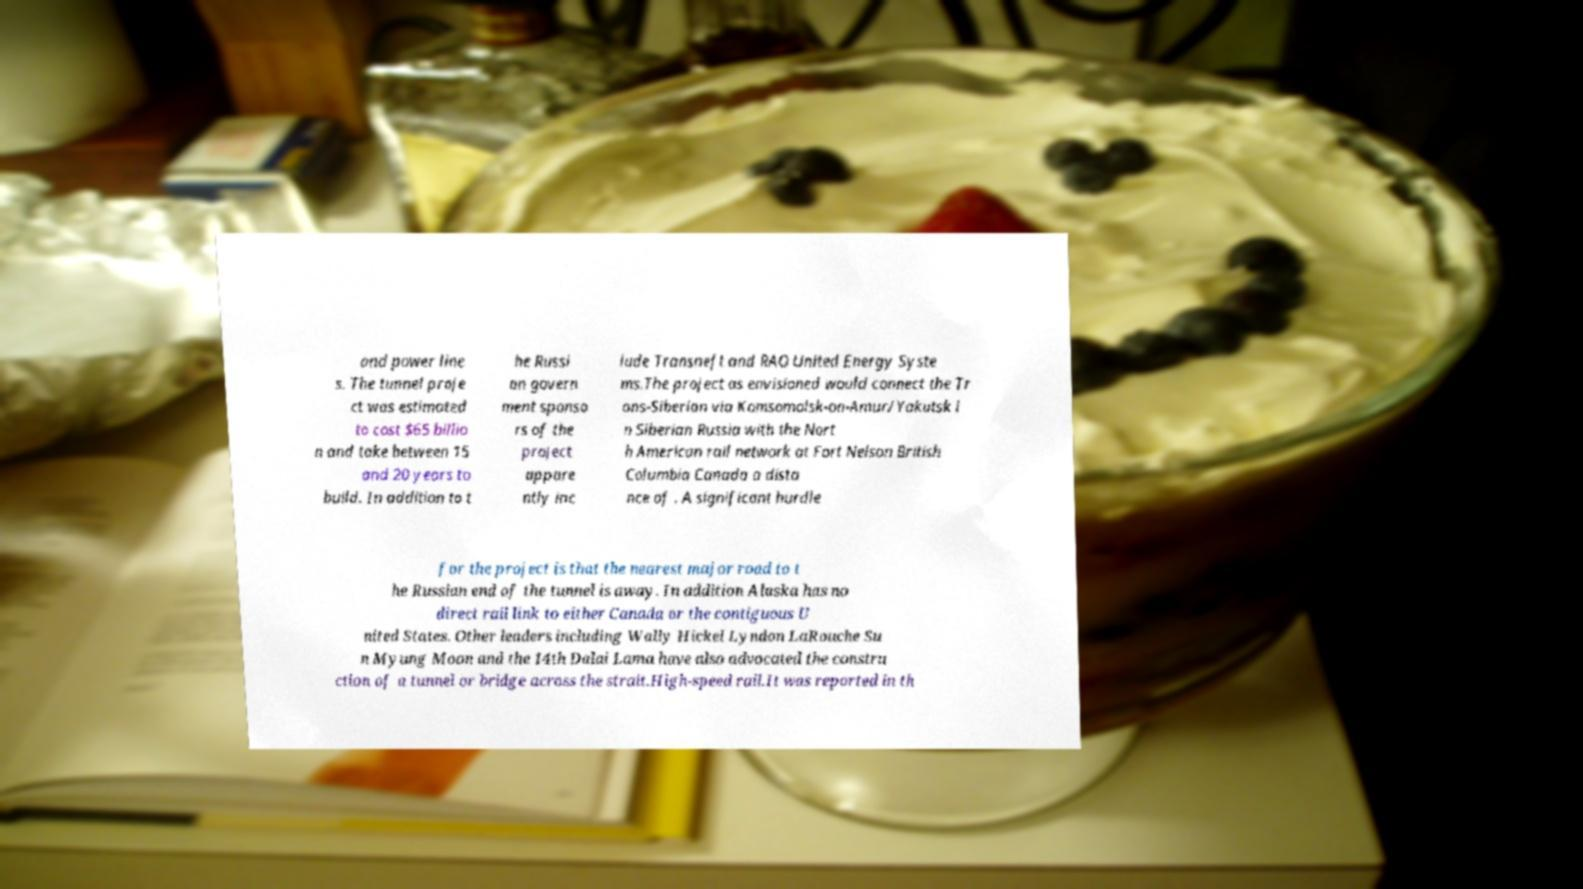I need the written content from this picture converted into text. Can you do that? and power line s. The tunnel proje ct was estimated to cost $65 billio n and take between 15 and 20 years to build. In addition to t he Russi an govern ment sponso rs of the project appare ntly inc lude Transneft and RAO United Energy Syste ms.The project as envisioned would connect the Tr ans-Siberian via Komsomolsk-on-Amur/Yakutsk i n Siberian Russia with the Nort h American rail network at Fort Nelson British Columbia Canada a dista nce of . A significant hurdle for the project is that the nearest major road to t he Russian end of the tunnel is away. In addition Alaska has no direct rail link to either Canada or the contiguous U nited States. Other leaders including Wally Hickel Lyndon LaRouche Su n Myung Moon and the 14th Dalai Lama have also advocated the constru ction of a tunnel or bridge across the strait.High-speed rail.It was reported in th 